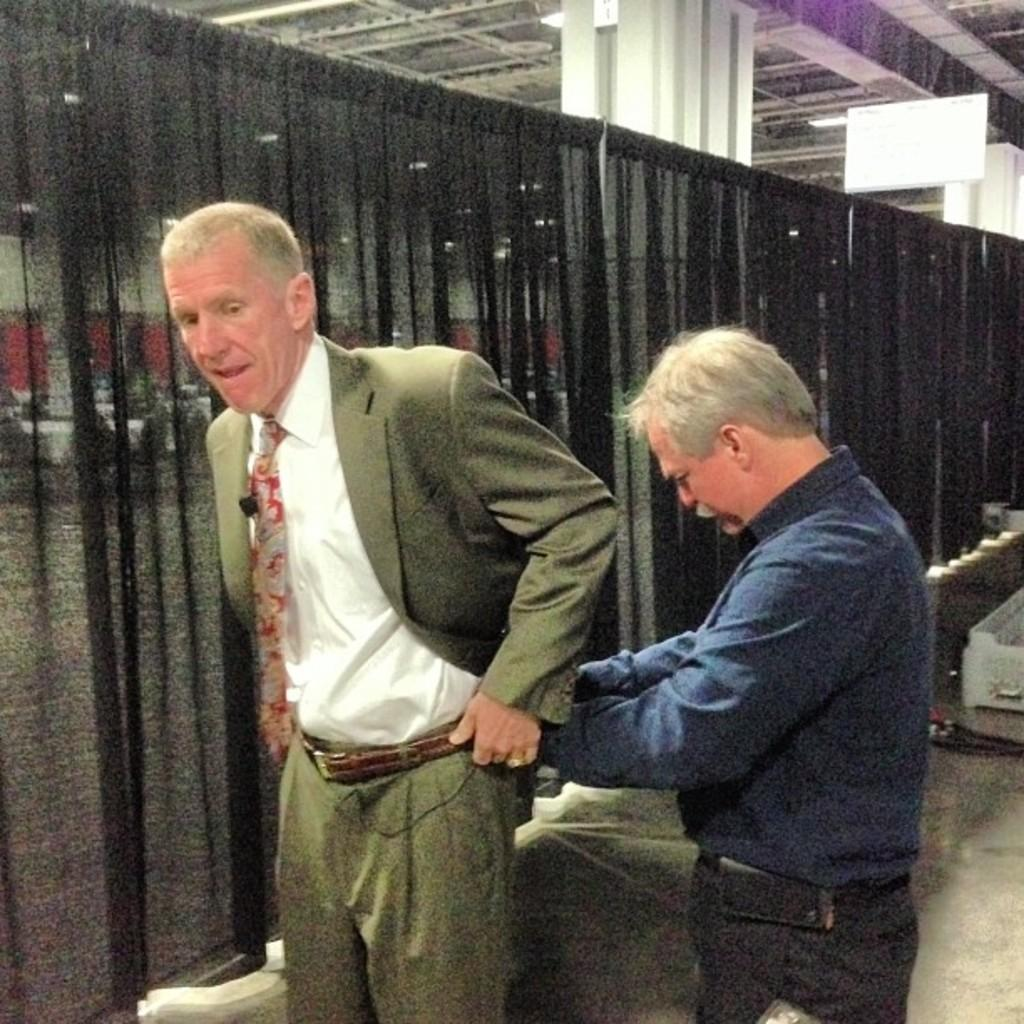How many people are in the image? There are two men in the image. What is the man wearing a blue shirt and black pants doing? The information provided does not specify any actions or activities of the men. What is the other man wearing? The other man is wearing a green suit. What can be seen in the background of the image? There is a black curtain in the background of the image. What type of dolls can be seen in the image? There are no dolls present in the image. What are the men laughing about in the image? The information provided does not mention any laughter or conversation between the men. 